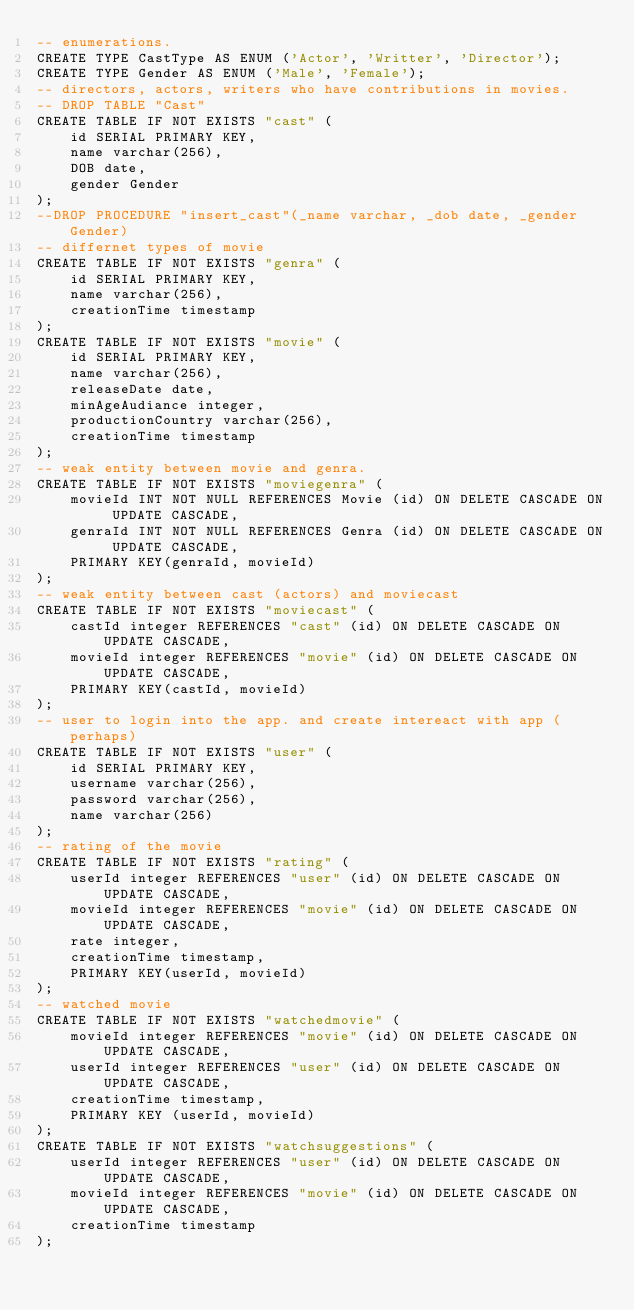<code> <loc_0><loc_0><loc_500><loc_500><_SQL_>-- enumerations.
CREATE TYPE CastType AS ENUM ('Actor', 'Writter', 'Director');
CREATE TYPE Gender AS ENUM ('Male', 'Female');
-- directors, actors, writers who have contributions in movies.
-- DROP TABLE "Cast"
CREATE TABLE IF NOT EXISTS "cast" (
    id SERIAL PRIMARY KEY,
    name varchar(256),
    DOB date,
    gender Gender
);
--DROP PROCEDURE "insert_cast"(_name varchar, _dob date, _gender Gender)
-- differnet types of movie 
CREATE TABLE IF NOT EXISTS "genra" (
    id SERIAL PRIMARY KEY,
    name varchar(256),
    creationTime timestamp
);
CREATE TABLE IF NOT EXISTS "movie" (
    id SERIAL PRIMARY KEY,
    name varchar(256),
    releaseDate date,
    minAgeAudiance integer,
    productionCountry varchar(256),
    creationTime timestamp
);
-- weak entity between movie and genra.
CREATE TABLE IF NOT EXISTS "moviegenra" (
    movieId INT NOT NULL REFERENCES Movie (id) ON DELETE CASCADE ON UPDATE CASCADE,
    genraId INT NOT NULL REFERENCES Genra (id) ON DELETE CASCADE ON UPDATE CASCADE,
    PRIMARY KEY(genraId, movieId)
);
-- weak entity between cast (actors) and moviecast
CREATE TABLE IF NOT EXISTS "moviecast" (
    castId integer REFERENCES "cast" (id) ON DELETE CASCADE ON UPDATE CASCADE,
    movieId integer REFERENCES "movie" (id) ON DELETE CASCADE ON UPDATE CASCADE,
    PRIMARY KEY(castId, movieId)
);
-- user to login into the app. and create intereact with app (perhaps)
CREATE TABLE IF NOT EXISTS "user" (
    id SERIAL PRIMARY KEY,
    username varchar(256),
    password varchar(256),
    name varchar(256)
);
-- rating of the movie
CREATE TABLE IF NOT EXISTS "rating" (
    userId integer REFERENCES "user" (id) ON DELETE CASCADE ON UPDATE CASCADE,
    movieId integer REFERENCES "movie" (id) ON DELETE CASCADE ON UPDATE CASCADE,
    rate integer,
    creationTime timestamp,
    PRIMARY KEY(userId, movieId)
);
-- watched movie
CREATE TABLE IF NOT EXISTS "watchedmovie" (
    movieId integer REFERENCES "movie" (id) ON DELETE CASCADE ON UPDATE CASCADE,
    userId integer REFERENCES "user" (id) ON DELETE CASCADE ON UPDATE CASCADE,
    creationTime timestamp,
    PRIMARY KEY (userId, movieId)
);
CREATE TABLE IF NOT EXISTS "watchsuggestions" (
    userId integer REFERENCES "user" (id) ON DELETE CASCADE ON UPDATE CASCADE,
    movieId integer REFERENCES "movie" (id) ON DELETE CASCADE ON UPDATE CASCADE,
    creationTime timestamp
);</code> 